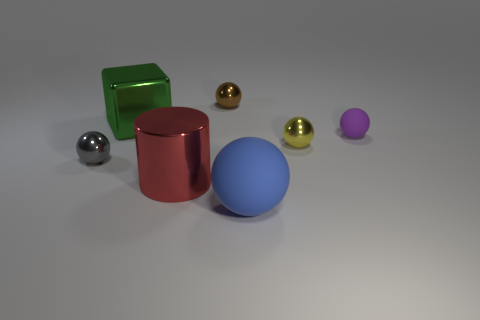What number of objects are either red objects on the left side of the yellow thing or matte things on the right side of the blue thing?
Ensure brevity in your answer.  2. Does the big rubber ball have the same color as the small rubber object?
Ensure brevity in your answer.  No. Are there fewer small metallic balls that are in front of the metallic block than tiny metal spheres that are behind the yellow object?
Your response must be concise. No. Is the material of the gray object the same as the large red thing?
Provide a short and direct response. Yes. There is a sphere that is behind the tiny yellow thing and to the left of the tiny purple rubber thing; what is its size?
Your answer should be very brief. Small. What is the shape of the green metal object that is the same size as the red metallic cylinder?
Ensure brevity in your answer.  Cube. What material is the object behind the large green thing on the left side of the large metallic thing in front of the gray metal object made of?
Provide a succinct answer. Metal. There is a small metal object that is behind the small yellow metal thing; does it have the same shape as the tiny metal object on the left side of the brown shiny object?
Provide a succinct answer. Yes. What number of other objects are there of the same material as the cylinder?
Your response must be concise. 4. Is the material of the tiny ball behind the tiny purple rubber thing the same as the tiny object to the right of the tiny yellow sphere?
Offer a very short reply. No. 